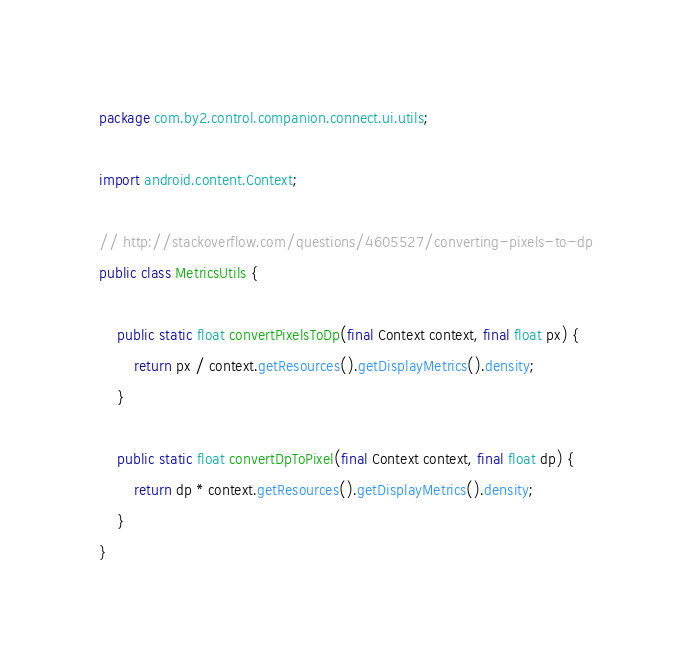<code> <loc_0><loc_0><loc_500><loc_500><_Java_>package com.by2.control.companion.connect.ui.utils;

import android.content.Context;

// http://stackoverflow.com/questions/4605527/converting-pixels-to-dp
public class MetricsUtils {

    public static float convertPixelsToDp(final Context context, final float px) {
        return px / context.getResources().getDisplayMetrics().density;
    }

    public static float convertDpToPixel(final Context context, final float dp) {
        return dp * context.getResources().getDisplayMetrics().density;
    }
}
</code> 